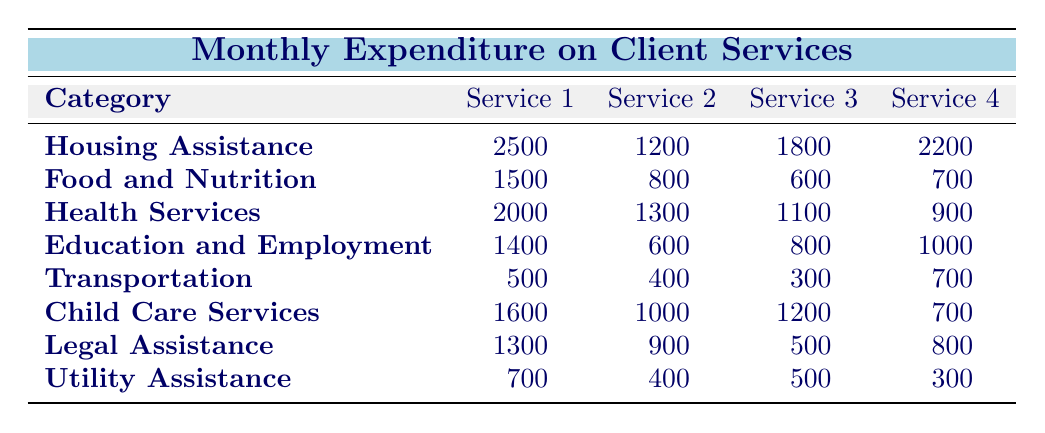What's the total expenditure on Housing Assistance? To find the total expenditure on Housing Assistance, I need to sum the values for Rent Supplements, Emergency Shelter Costs, Mortgage Payment Assistance, and Transitional Housing Costs. The sum is 2500 + 1200 + 1800 + 2200 = 8700.
Answer: 8700 Which category has the highest expenditure on Food and Nutrition? The expenditures for Food and Nutrition are Grocery Vouchers (1500), Meal Programs (800), Food Pantries (600), and Community Kitchens (700). The highest expenditure is Grocery Vouchers at 1500.
Answer: Grocery Vouchers Are the expenditures on Legal Assistance higher than those on Transportation? The total for Legal Assistance is 1300 + 900 + 500 + 800 = 3500. The total for Transportation is 500 + 400 + 300 + 700 = 1900. Since 3500 > 1900, the expenditures on Legal Assistance are higher.
Answer: Yes What is the average expenditure across all categories for Child Care Services? To find the average, I need to sum the expenditures for Child Care Services: Daycare Subsidies (1600), After-School Programs (1000), Summer Camps (1200), and Respite Care (700). The total is 1600 + 1000 + 1200 + 700 = 3500. There are 4 services, so the average is 3500 / 4 = 875.
Answer: 875 Which category has a total expenditure of less than 2500? I will sum the expenditures for each category and check if any total is less than 2500. The totals are: Housing Assistance (8700), Food and Nutrition (3600), Health Services (4300), Education and Employment (3800), Transportation (1900), Child Care Services (3500), Legal Assistance (3500), Utility Assistance (1900). The categories with totals less than 2500 are Transportation and Utility Assistance.
Answer: Transportation and Utility Assistance What is the total expenditure across all categories on Health Services? To calculate the total expenditure on Health Services, I sum the expenditures: Medical Assistance (2000), Mental Health Counseling (1300), Substance Abuse Treatment (1100), and Dental Care Vouchers (900). The total is 2000 + 1300 + 1100 + 900 = 6300.
Answer: 6300 